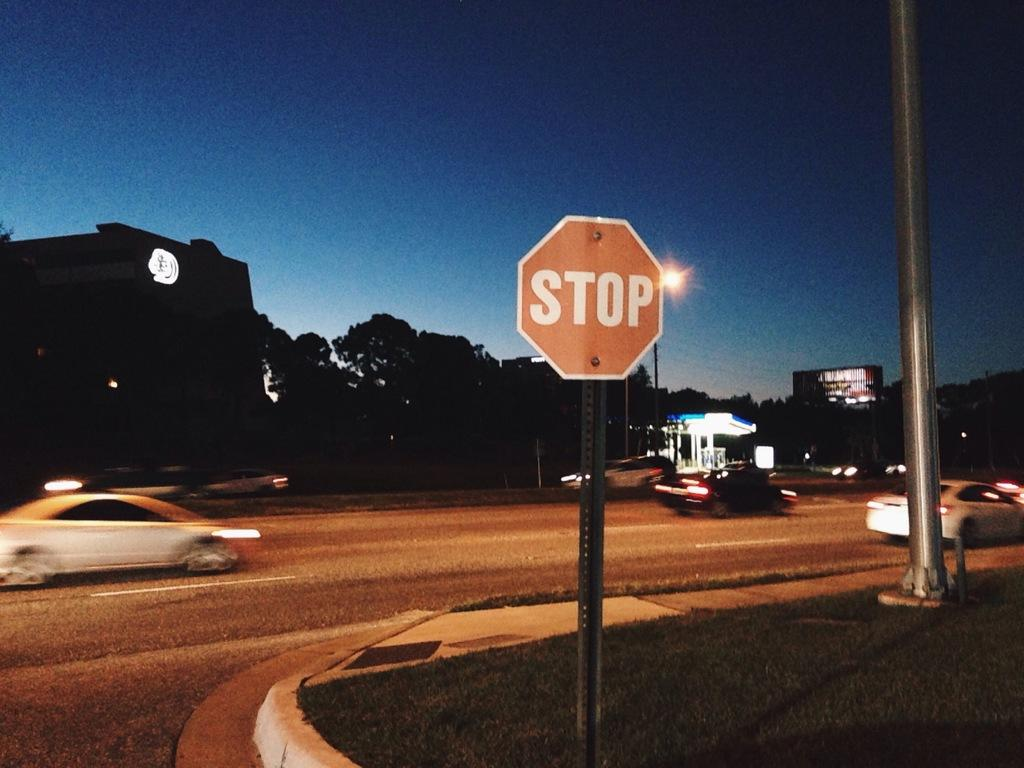<image>
Offer a succinct explanation of the picture presented. A stop sign is posted on a street corner at night. 